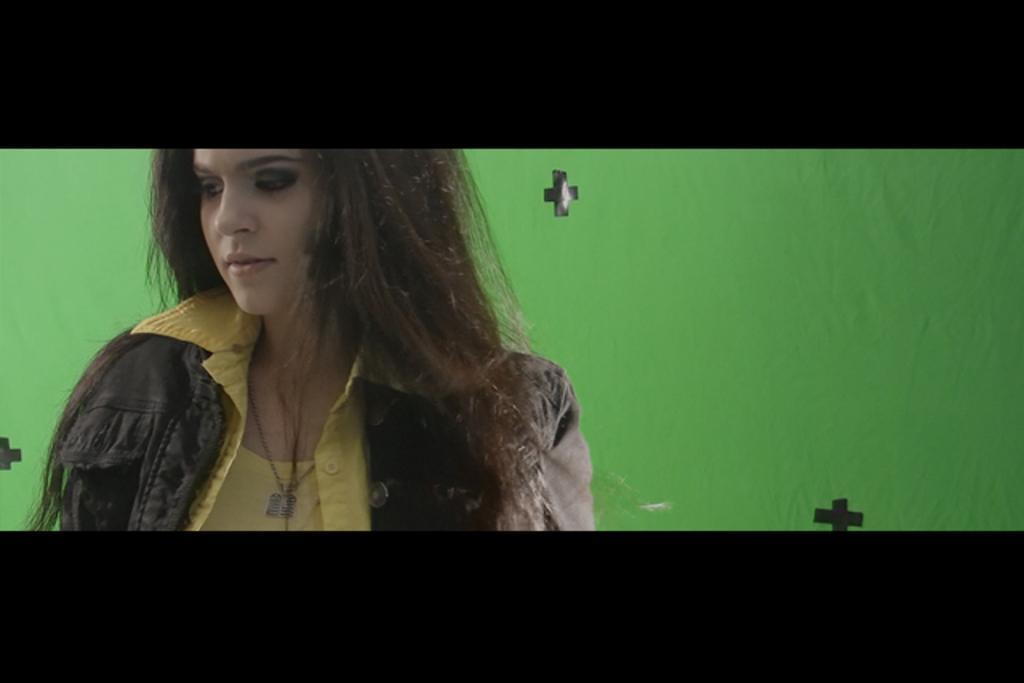In one or two sentences, can you explain what this image depicts? In this image I can see a person and the person is wearing gray color jacket and yellow color shirt and I can see green color background. 